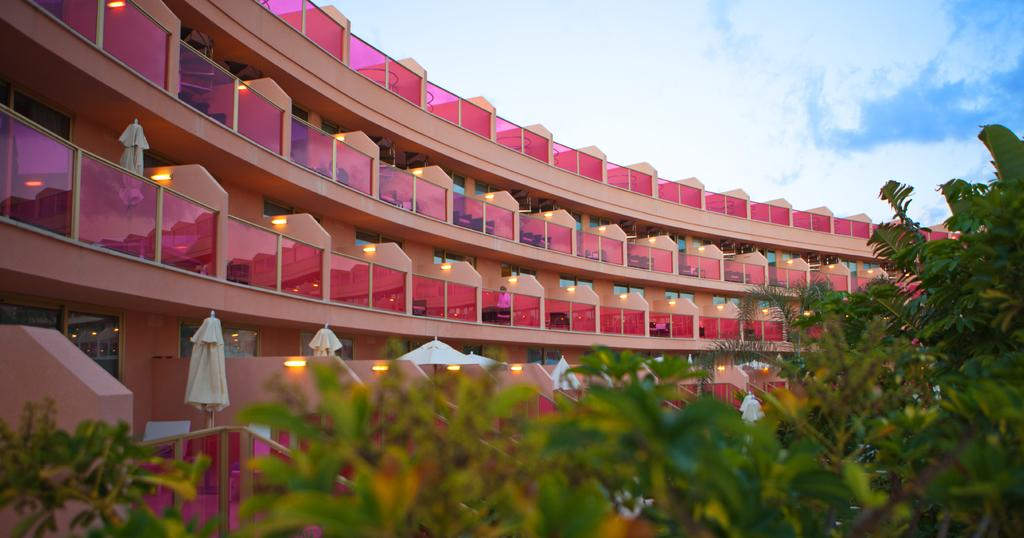What structure is located on the left side of the image? There is a building on the left side of the image. What can be seen at the bottom of the image? Trees, umbrellas, clothes, lights, and glasses are visible at the bottom of the image. What is visible in the sky at the top of the image? The sky is visible at the top of the image, and clouds are present in the sky. Where is the box located in the image? There is no box present in the image. What type of band is playing music in the image? There is no band present in the image. 